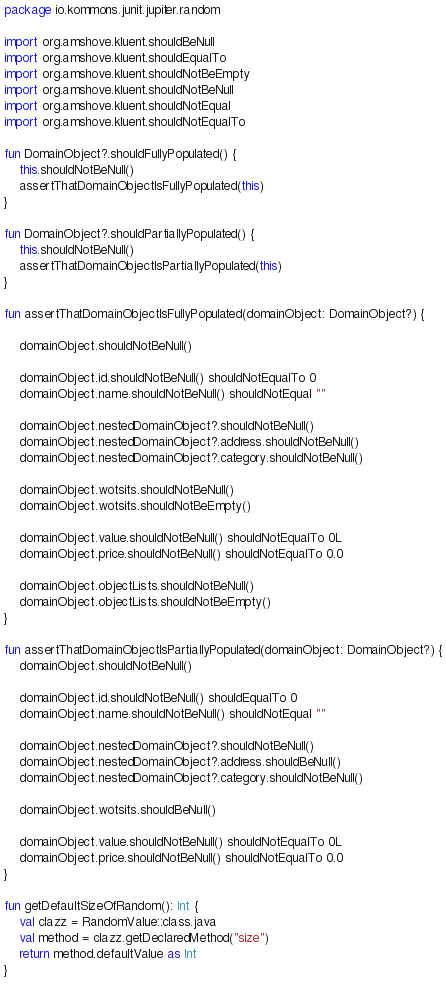Convert code to text. <code><loc_0><loc_0><loc_500><loc_500><_Kotlin_>package io.kommons.junit.jupiter.random

import org.amshove.kluent.shouldBeNull
import org.amshove.kluent.shouldEqualTo
import org.amshove.kluent.shouldNotBeEmpty
import org.amshove.kluent.shouldNotBeNull
import org.amshove.kluent.shouldNotEqual
import org.amshove.kluent.shouldNotEqualTo

fun DomainObject?.shouldFullyPopulated() {
    this.shouldNotBeNull()
    assertThatDomainObjectIsFullyPopulated(this)
}

fun DomainObject?.shouldPartiallyPopulated() {
    this.shouldNotBeNull()
    assertThatDomainObjectIsPartiallyPopulated(this)
}

fun assertThatDomainObjectIsFullyPopulated(domainObject: DomainObject?) {

    domainObject.shouldNotBeNull()

    domainObject.id.shouldNotBeNull() shouldNotEqualTo 0
    domainObject.name.shouldNotBeNull() shouldNotEqual ""

    domainObject.nestedDomainObject?.shouldNotBeNull()
    domainObject.nestedDomainObject?.address.shouldNotBeNull()
    domainObject.nestedDomainObject?.category.shouldNotBeNull()

    domainObject.wotsits.shouldNotBeNull()
    domainObject.wotsits.shouldNotBeEmpty()

    domainObject.value.shouldNotBeNull() shouldNotEqualTo 0L
    domainObject.price.shouldNotBeNull() shouldNotEqualTo 0.0

    domainObject.objectLists.shouldNotBeNull()
    domainObject.objectLists.shouldNotBeEmpty()
}

fun assertThatDomainObjectIsPartiallyPopulated(domainObject: DomainObject?) {
    domainObject.shouldNotBeNull()

    domainObject.id.shouldNotBeNull() shouldEqualTo 0
    domainObject.name.shouldNotBeNull() shouldNotEqual ""

    domainObject.nestedDomainObject?.shouldNotBeNull()
    domainObject.nestedDomainObject?.address.shouldBeNull()
    domainObject.nestedDomainObject?.category.shouldNotBeNull()

    domainObject.wotsits.shouldBeNull()

    domainObject.value.shouldNotBeNull() shouldNotEqualTo 0L
    domainObject.price.shouldNotBeNull() shouldNotEqualTo 0.0
}

fun getDefaultSizeOfRandom(): Int {
    val clazz = RandomValue::class.java
    val method = clazz.getDeclaredMethod("size")
    return method.defaultValue as Int
}</code> 